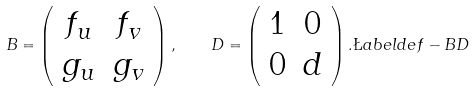Convert formula to latex. <formula><loc_0><loc_0><loc_500><loc_500>B = \left ( \begin{array} { c c } f _ { u } & f _ { v } \\ g _ { u } & g _ { v } \end{array} \right ) , \quad D = \left ( \begin{array} { c c } 1 & 0 \\ 0 & d \end{array} \right ) . \L a b e l { d e f - B D }</formula> 